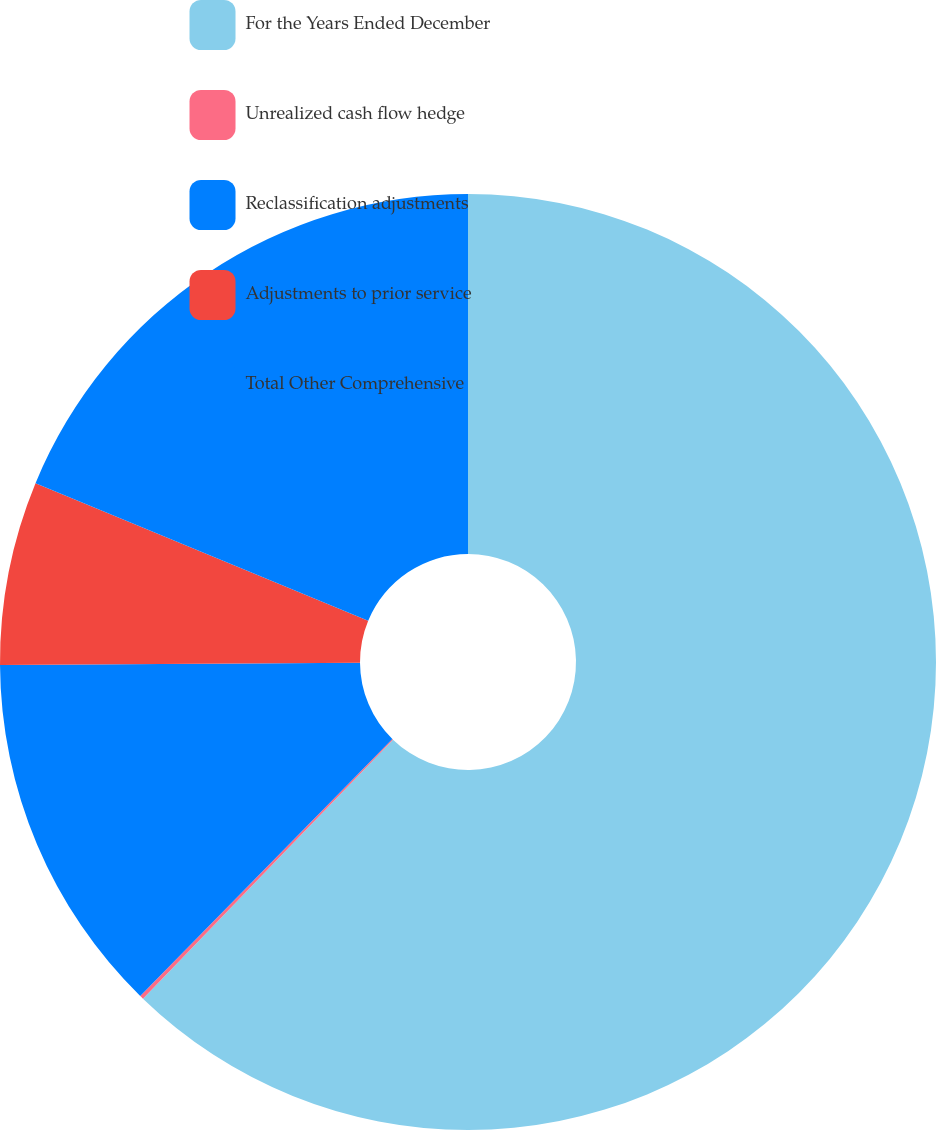<chart> <loc_0><loc_0><loc_500><loc_500><pie_chart><fcel>For the Years Ended December<fcel>Unrealized cash flow hedge<fcel>Reclassification adjustments<fcel>Adjustments to prior service<fcel>Total Other Comprehensive<nl><fcel>62.22%<fcel>0.13%<fcel>12.55%<fcel>6.34%<fcel>18.76%<nl></chart> 